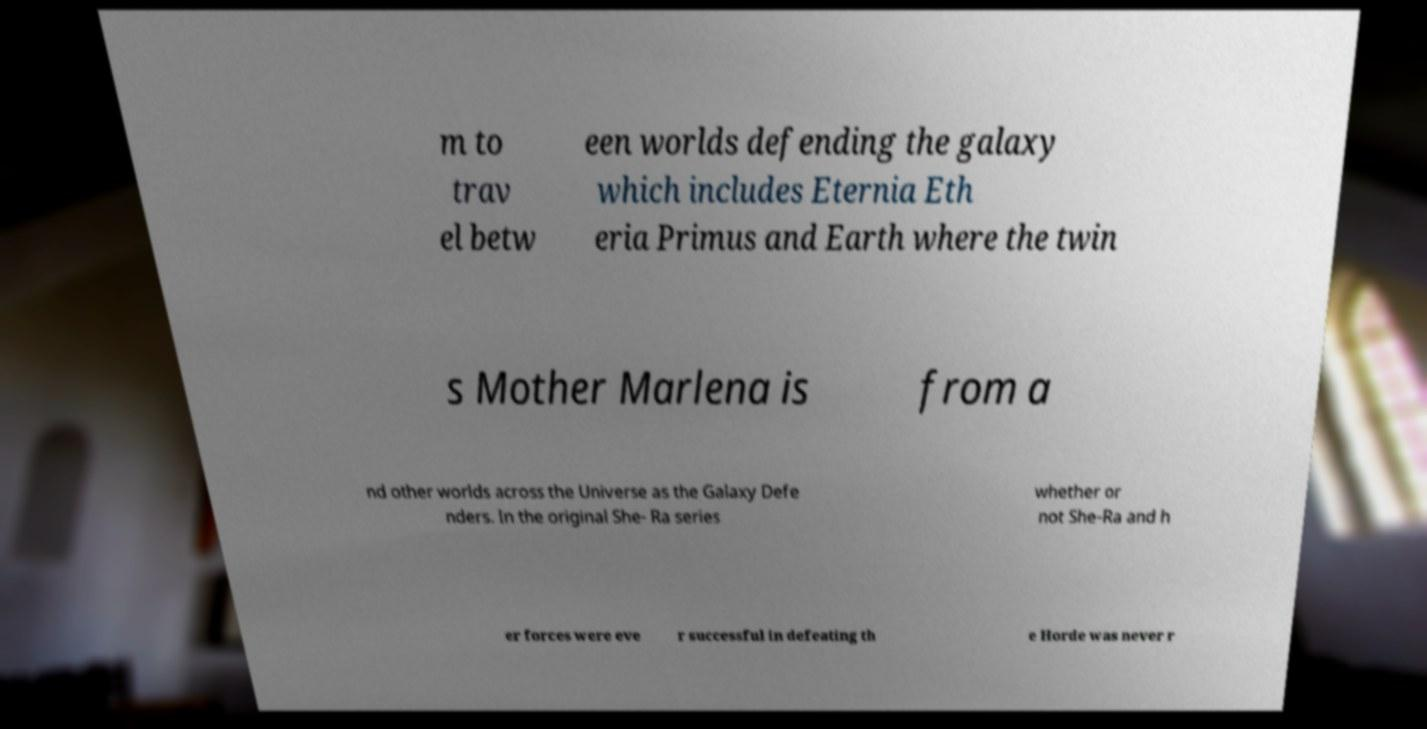I need the written content from this picture converted into text. Can you do that? m to trav el betw een worlds defending the galaxy which includes Eternia Eth eria Primus and Earth where the twin s Mother Marlena is from a nd other worlds across the Universe as the Galaxy Defe nders. In the original She- Ra series whether or not She-Ra and h er forces were eve r successful in defeating th e Horde was never r 